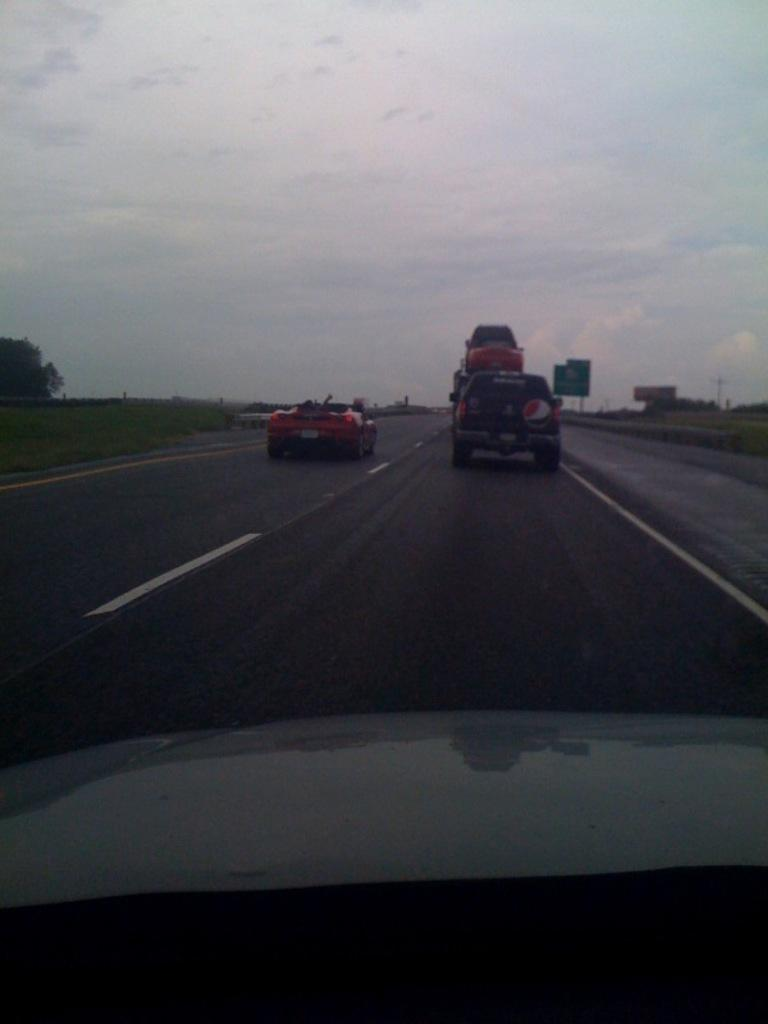What can be seen on the road in the image? There are vehicles on the road in the image. What type of natural elements are visible in the background of the image? There are trees in the background of the image. What other objects can be seen in the background of the image? There are poles and boards in the background of the image. What is visible at the top of the image? The sky is visible at the top of the image. What type of vegetable is growing in the yard in the image? There is no yard or vegetable present in the image. What type of vacation is being taken in the image? There is no indication of a vacation in the image; it shows vehicles on a road with trees, poles, and boards in the background. 